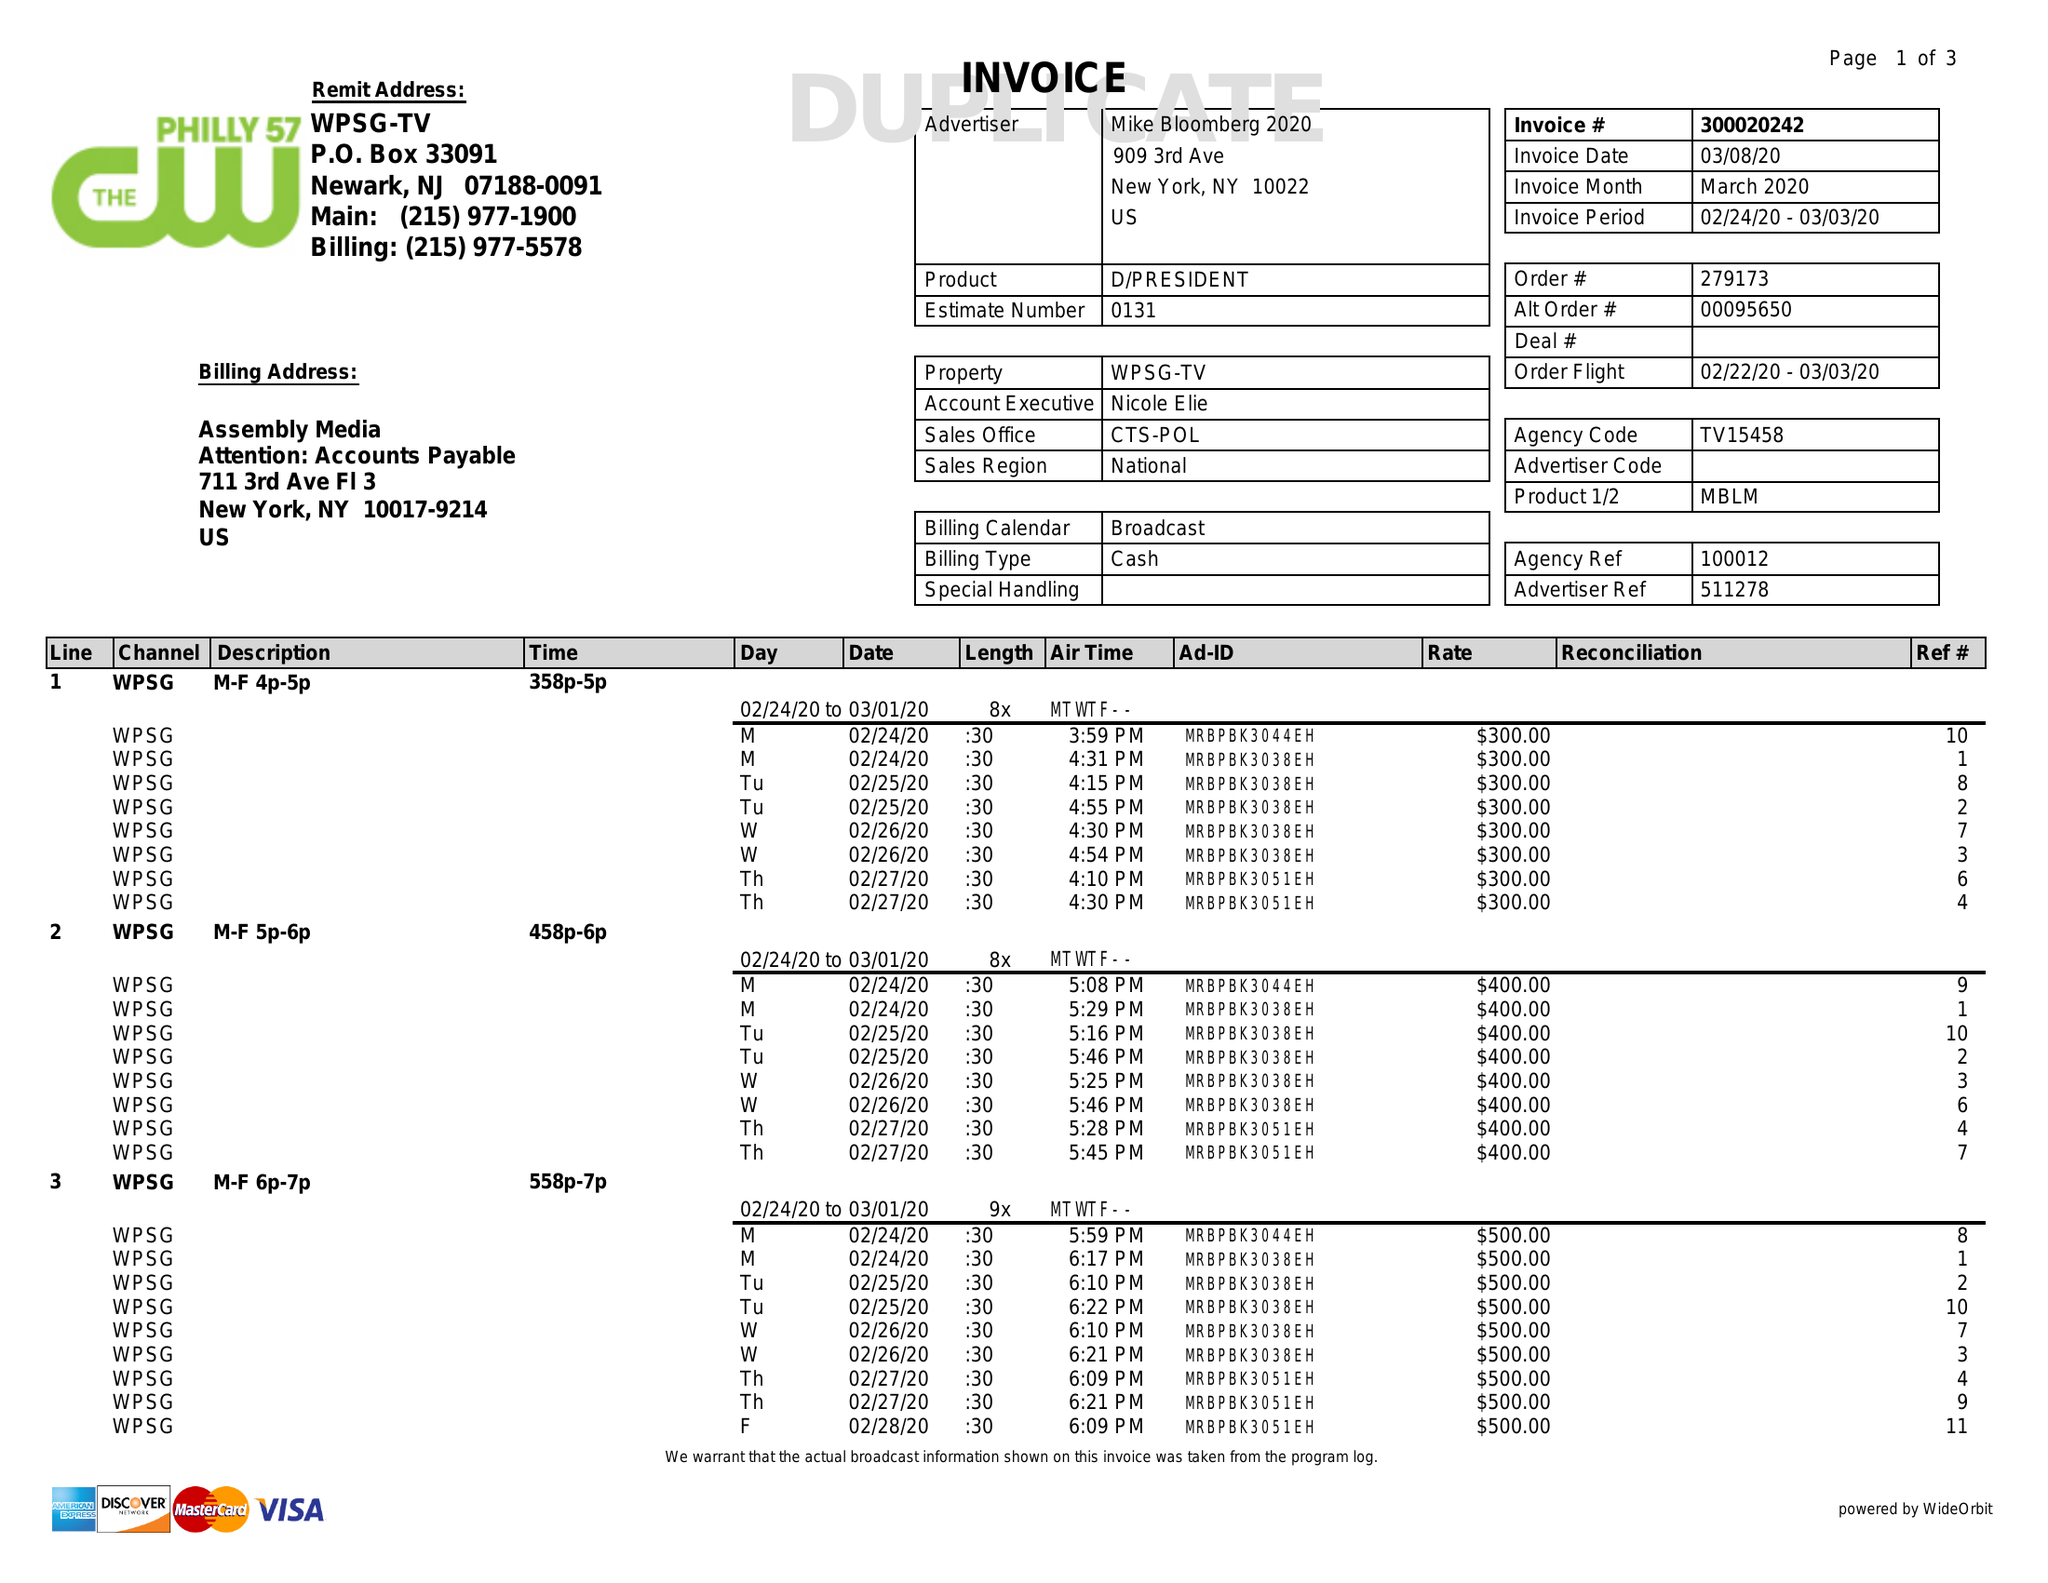What is the value for the flight_from?
Answer the question using a single word or phrase. 02/22/20 